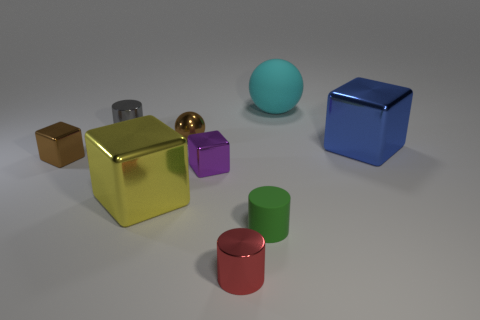Can you describe the colors and shapes of the objects in the image? Certainly! The image features a variety of objects in different colors and shapes. Starting from the left, there's a small brown cube, a larger gold cube, a tiny gold sphere, a small purple cube, a medium-sized green cylinder, a large red cylinder, a teal sphere, and a tiny blue metallic cube on the far right. 